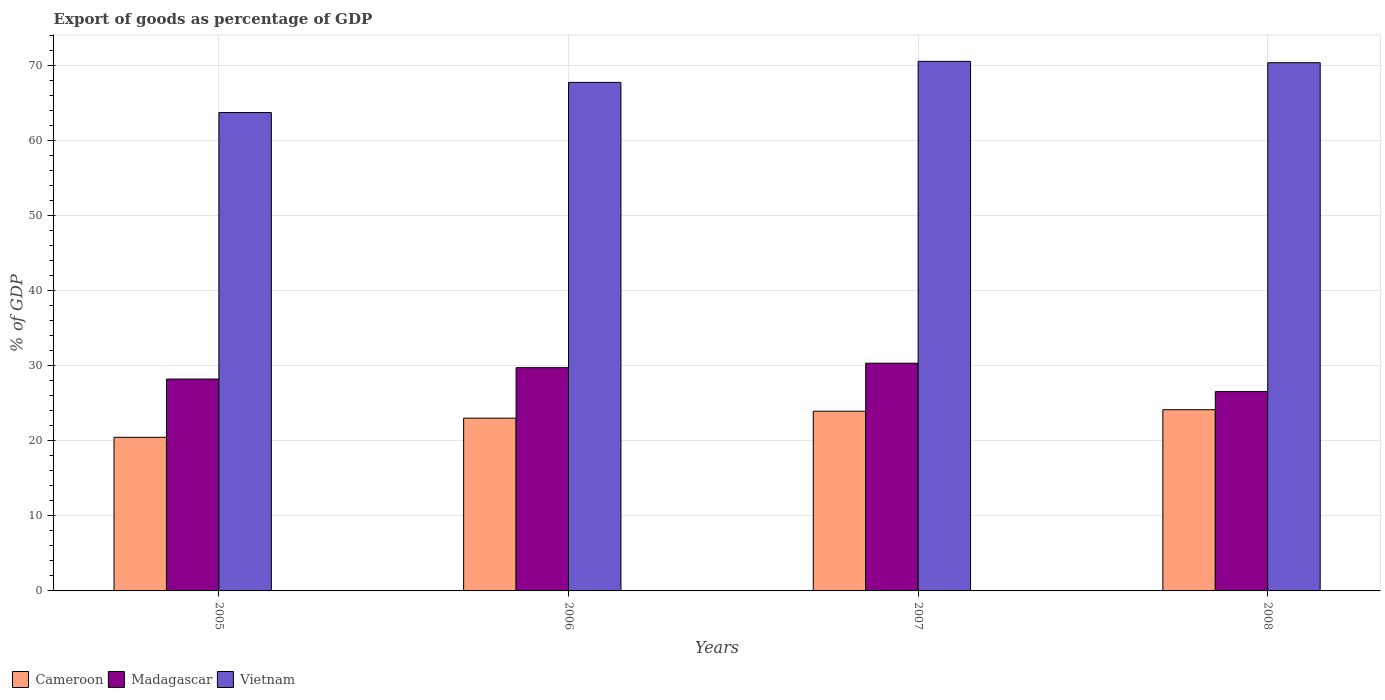How many groups of bars are there?
Your response must be concise. 4. Are the number of bars on each tick of the X-axis equal?
Make the answer very short. Yes. How many bars are there on the 2nd tick from the right?
Give a very brief answer. 3. What is the label of the 2nd group of bars from the left?
Offer a very short reply. 2006. What is the export of goods as percentage of GDP in Cameroon in 2005?
Offer a terse response. 20.45. Across all years, what is the maximum export of goods as percentage of GDP in Cameroon?
Make the answer very short. 24.13. Across all years, what is the minimum export of goods as percentage of GDP in Cameroon?
Ensure brevity in your answer.  20.45. In which year was the export of goods as percentage of GDP in Madagascar minimum?
Offer a very short reply. 2008. What is the total export of goods as percentage of GDP in Vietnam in the graph?
Keep it short and to the point. 272.27. What is the difference between the export of goods as percentage of GDP in Madagascar in 2005 and that in 2006?
Keep it short and to the point. -1.52. What is the difference between the export of goods as percentage of GDP in Cameroon in 2008 and the export of goods as percentage of GDP in Madagascar in 2006?
Provide a short and direct response. -5.6. What is the average export of goods as percentage of GDP in Cameroon per year?
Your response must be concise. 22.88. In the year 2005, what is the difference between the export of goods as percentage of GDP in Cameroon and export of goods as percentage of GDP in Madagascar?
Your answer should be compact. -7.76. In how many years, is the export of goods as percentage of GDP in Cameroon greater than 34 %?
Make the answer very short. 0. What is the ratio of the export of goods as percentage of GDP in Madagascar in 2005 to that in 2007?
Your answer should be very brief. 0.93. What is the difference between the highest and the second highest export of goods as percentage of GDP in Vietnam?
Provide a succinct answer. 0.18. What is the difference between the highest and the lowest export of goods as percentage of GDP in Vietnam?
Offer a very short reply. 6.82. In how many years, is the export of goods as percentage of GDP in Madagascar greater than the average export of goods as percentage of GDP in Madagascar taken over all years?
Provide a short and direct response. 2. What does the 2nd bar from the left in 2005 represents?
Your response must be concise. Madagascar. What does the 1st bar from the right in 2006 represents?
Offer a very short reply. Vietnam. Is it the case that in every year, the sum of the export of goods as percentage of GDP in Cameroon and export of goods as percentage of GDP in Vietnam is greater than the export of goods as percentage of GDP in Madagascar?
Make the answer very short. Yes. How many bars are there?
Give a very brief answer. 12. Are all the bars in the graph horizontal?
Keep it short and to the point. No. Where does the legend appear in the graph?
Your response must be concise. Bottom left. How many legend labels are there?
Offer a terse response. 3. What is the title of the graph?
Keep it short and to the point. Export of goods as percentage of GDP. What is the label or title of the Y-axis?
Your answer should be compact. % of GDP. What is the % of GDP in Cameroon in 2005?
Offer a terse response. 20.45. What is the % of GDP of Madagascar in 2005?
Offer a very short reply. 28.21. What is the % of GDP in Vietnam in 2005?
Your answer should be compact. 63.7. What is the % of GDP of Cameroon in 2006?
Your response must be concise. 23. What is the % of GDP in Madagascar in 2006?
Your answer should be compact. 29.73. What is the % of GDP in Vietnam in 2006?
Make the answer very short. 67.72. What is the % of GDP of Cameroon in 2007?
Your response must be concise. 23.93. What is the % of GDP in Madagascar in 2007?
Provide a short and direct response. 30.32. What is the % of GDP of Vietnam in 2007?
Keep it short and to the point. 70.52. What is the % of GDP in Cameroon in 2008?
Offer a very short reply. 24.13. What is the % of GDP in Madagascar in 2008?
Offer a terse response. 26.54. What is the % of GDP in Vietnam in 2008?
Give a very brief answer. 70.34. Across all years, what is the maximum % of GDP of Cameroon?
Keep it short and to the point. 24.13. Across all years, what is the maximum % of GDP of Madagascar?
Offer a very short reply. 30.32. Across all years, what is the maximum % of GDP of Vietnam?
Your answer should be compact. 70.52. Across all years, what is the minimum % of GDP of Cameroon?
Make the answer very short. 20.45. Across all years, what is the minimum % of GDP in Madagascar?
Provide a short and direct response. 26.54. Across all years, what is the minimum % of GDP in Vietnam?
Provide a succinct answer. 63.7. What is the total % of GDP in Cameroon in the graph?
Keep it short and to the point. 91.52. What is the total % of GDP of Madagascar in the graph?
Give a very brief answer. 114.81. What is the total % of GDP of Vietnam in the graph?
Give a very brief answer. 272.27. What is the difference between the % of GDP of Cameroon in 2005 and that in 2006?
Your response must be concise. -2.55. What is the difference between the % of GDP of Madagascar in 2005 and that in 2006?
Your answer should be very brief. -1.52. What is the difference between the % of GDP of Vietnam in 2005 and that in 2006?
Your response must be concise. -4.02. What is the difference between the % of GDP in Cameroon in 2005 and that in 2007?
Offer a very short reply. -3.48. What is the difference between the % of GDP of Madagascar in 2005 and that in 2007?
Make the answer very short. -2.11. What is the difference between the % of GDP of Vietnam in 2005 and that in 2007?
Ensure brevity in your answer.  -6.82. What is the difference between the % of GDP in Cameroon in 2005 and that in 2008?
Provide a succinct answer. -3.68. What is the difference between the % of GDP of Madagascar in 2005 and that in 2008?
Your answer should be very brief. 1.67. What is the difference between the % of GDP of Vietnam in 2005 and that in 2008?
Make the answer very short. -6.64. What is the difference between the % of GDP in Cameroon in 2006 and that in 2007?
Offer a very short reply. -0.93. What is the difference between the % of GDP of Madagascar in 2006 and that in 2007?
Make the answer very short. -0.6. What is the difference between the % of GDP of Vietnam in 2006 and that in 2007?
Provide a short and direct response. -2.8. What is the difference between the % of GDP of Cameroon in 2006 and that in 2008?
Offer a terse response. -1.13. What is the difference between the % of GDP in Madagascar in 2006 and that in 2008?
Provide a succinct answer. 3.19. What is the difference between the % of GDP in Vietnam in 2006 and that in 2008?
Your response must be concise. -2.62. What is the difference between the % of GDP of Cameroon in 2007 and that in 2008?
Offer a very short reply. -0.2. What is the difference between the % of GDP in Madagascar in 2007 and that in 2008?
Provide a short and direct response. 3.78. What is the difference between the % of GDP in Vietnam in 2007 and that in 2008?
Make the answer very short. 0.18. What is the difference between the % of GDP of Cameroon in 2005 and the % of GDP of Madagascar in 2006?
Offer a very short reply. -9.27. What is the difference between the % of GDP of Cameroon in 2005 and the % of GDP of Vietnam in 2006?
Provide a short and direct response. -47.26. What is the difference between the % of GDP of Madagascar in 2005 and the % of GDP of Vietnam in 2006?
Ensure brevity in your answer.  -39.5. What is the difference between the % of GDP in Cameroon in 2005 and the % of GDP in Madagascar in 2007?
Ensure brevity in your answer.  -9.87. What is the difference between the % of GDP in Cameroon in 2005 and the % of GDP in Vietnam in 2007?
Your answer should be very brief. -50.06. What is the difference between the % of GDP in Madagascar in 2005 and the % of GDP in Vietnam in 2007?
Provide a short and direct response. -42.31. What is the difference between the % of GDP in Cameroon in 2005 and the % of GDP in Madagascar in 2008?
Offer a terse response. -6.09. What is the difference between the % of GDP in Cameroon in 2005 and the % of GDP in Vietnam in 2008?
Provide a succinct answer. -49.88. What is the difference between the % of GDP in Madagascar in 2005 and the % of GDP in Vietnam in 2008?
Offer a terse response. -42.12. What is the difference between the % of GDP in Cameroon in 2006 and the % of GDP in Madagascar in 2007?
Make the answer very short. -7.32. What is the difference between the % of GDP in Cameroon in 2006 and the % of GDP in Vietnam in 2007?
Make the answer very short. -47.51. What is the difference between the % of GDP of Madagascar in 2006 and the % of GDP of Vietnam in 2007?
Make the answer very short. -40.79. What is the difference between the % of GDP in Cameroon in 2006 and the % of GDP in Madagascar in 2008?
Give a very brief answer. -3.54. What is the difference between the % of GDP of Cameroon in 2006 and the % of GDP of Vietnam in 2008?
Ensure brevity in your answer.  -47.33. What is the difference between the % of GDP in Madagascar in 2006 and the % of GDP in Vietnam in 2008?
Your answer should be very brief. -40.61. What is the difference between the % of GDP in Cameroon in 2007 and the % of GDP in Madagascar in 2008?
Your answer should be compact. -2.61. What is the difference between the % of GDP in Cameroon in 2007 and the % of GDP in Vietnam in 2008?
Keep it short and to the point. -46.41. What is the difference between the % of GDP in Madagascar in 2007 and the % of GDP in Vietnam in 2008?
Offer a very short reply. -40.01. What is the average % of GDP in Cameroon per year?
Your answer should be compact. 22.88. What is the average % of GDP of Madagascar per year?
Provide a short and direct response. 28.7. What is the average % of GDP in Vietnam per year?
Provide a short and direct response. 68.07. In the year 2005, what is the difference between the % of GDP in Cameroon and % of GDP in Madagascar?
Offer a very short reply. -7.76. In the year 2005, what is the difference between the % of GDP in Cameroon and % of GDP in Vietnam?
Offer a very short reply. -43.24. In the year 2005, what is the difference between the % of GDP in Madagascar and % of GDP in Vietnam?
Ensure brevity in your answer.  -35.49. In the year 2006, what is the difference between the % of GDP of Cameroon and % of GDP of Madagascar?
Give a very brief answer. -6.72. In the year 2006, what is the difference between the % of GDP in Cameroon and % of GDP in Vietnam?
Give a very brief answer. -44.71. In the year 2006, what is the difference between the % of GDP in Madagascar and % of GDP in Vietnam?
Make the answer very short. -37.99. In the year 2007, what is the difference between the % of GDP in Cameroon and % of GDP in Madagascar?
Your answer should be very brief. -6.39. In the year 2007, what is the difference between the % of GDP in Cameroon and % of GDP in Vietnam?
Your answer should be very brief. -46.59. In the year 2007, what is the difference between the % of GDP of Madagascar and % of GDP of Vietnam?
Offer a terse response. -40.19. In the year 2008, what is the difference between the % of GDP in Cameroon and % of GDP in Madagascar?
Your answer should be compact. -2.41. In the year 2008, what is the difference between the % of GDP of Cameroon and % of GDP of Vietnam?
Offer a very short reply. -46.21. In the year 2008, what is the difference between the % of GDP in Madagascar and % of GDP in Vietnam?
Ensure brevity in your answer.  -43.8. What is the ratio of the % of GDP of Cameroon in 2005 to that in 2006?
Keep it short and to the point. 0.89. What is the ratio of the % of GDP in Madagascar in 2005 to that in 2006?
Make the answer very short. 0.95. What is the ratio of the % of GDP in Vietnam in 2005 to that in 2006?
Provide a short and direct response. 0.94. What is the ratio of the % of GDP in Cameroon in 2005 to that in 2007?
Your response must be concise. 0.85. What is the ratio of the % of GDP of Madagascar in 2005 to that in 2007?
Provide a short and direct response. 0.93. What is the ratio of the % of GDP in Vietnam in 2005 to that in 2007?
Give a very brief answer. 0.9. What is the ratio of the % of GDP in Cameroon in 2005 to that in 2008?
Your answer should be compact. 0.85. What is the ratio of the % of GDP of Madagascar in 2005 to that in 2008?
Provide a succinct answer. 1.06. What is the ratio of the % of GDP in Vietnam in 2005 to that in 2008?
Your answer should be compact. 0.91. What is the ratio of the % of GDP in Cameroon in 2006 to that in 2007?
Provide a succinct answer. 0.96. What is the ratio of the % of GDP in Madagascar in 2006 to that in 2007?
Offer a very short reply. 0.98. What is the ratio of the % of GDP in Vietnam in 2006 to that in 2007?
Give a very brief answer. 0.96. What is the ratio of the % of GDP in Cameroon in 2006 to that in 2008?
Give a very brief answer. 0.95. What is the ratio of the % of GDP in Madagascar in 2006 to that in 2008?
Provide a short and direct response. 1.12. What is the ratio of the % of GDP in Vietnam in 2006 to that in 2008?
Give a very brief answer. 0.96. What is the ratio of the % of GDP of Madagascar in 2007 to that in 2008?
Give a very brief answer. 1.14. What is the ratio of the % of GDP of Vietnam in 2007 to that in 2008?
Your answer should be very brief. 1. What is the difference between the highest and the second highest % of GDP of Cameroon?
Your answer should be compact. 0.2. What is the difference between the highest and the second highest % of GDP of Madagascar?
Provide a short and direct response. 0.6. What is the difference between the highest and the second highest % of GDP in Vietnam?
Your answer should be very brief. 0.18. What is the difference between the highest and the lowest % of GDP in Cameroon?
Keep it short and to the point. 3.68. What is the difference between the highest and the lowest % of GDP of Madagascar?
Give a very brief answer. 3.78. What is the difference between the highest and the lowest % of GDP in Vietnam?
Keep it short and to the point. 6.82. 